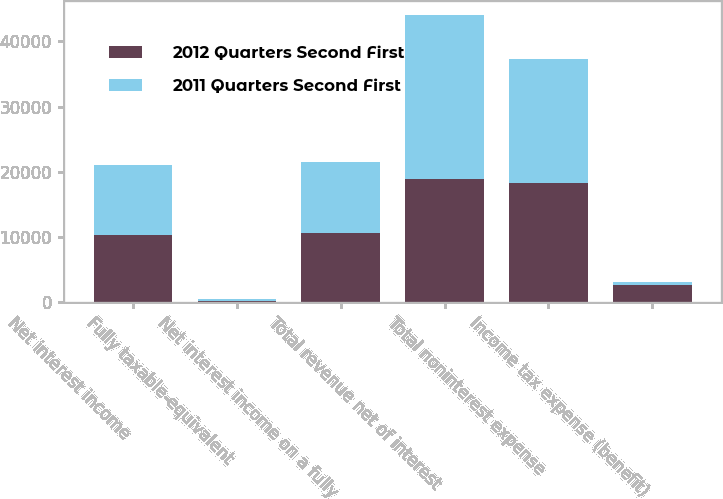<chart> <loc_0><loc_0><loc_500><loc_500><stacked_bar_chart><ecel><fcel>Net interest income<fcel>Fully taxable-equivalent<fcel>Net interest income on a fully<fcel>Total revenue net of interest<fcel>Total noninterest expense<fcel>Income tax expense (benefit)<nl><fcel>2012 Quarters Second First<fcel>10324<fcel>231<fcel>10555<fcel>18891<fcel>18360<fcel>2636<nl><fcel>2011 Quarters Second First<fcel>10701<fcel>258<fcel>10959<fcel>25146<fcel>18941<fcel>441<nl></chart> 